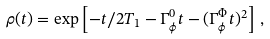Convert formula to latex. <formula><loc_0><loc_0><loc_500><loc_500>\rho ( t ) = \exp \left [ - t / 2 T _ { 1 } - \Gamma _ { \phi } ^ { 0 } t - ( \Gamma _ { \phi } ^ { \Phi } t ) ^ { 2 } \right ] \, ,</formula> 